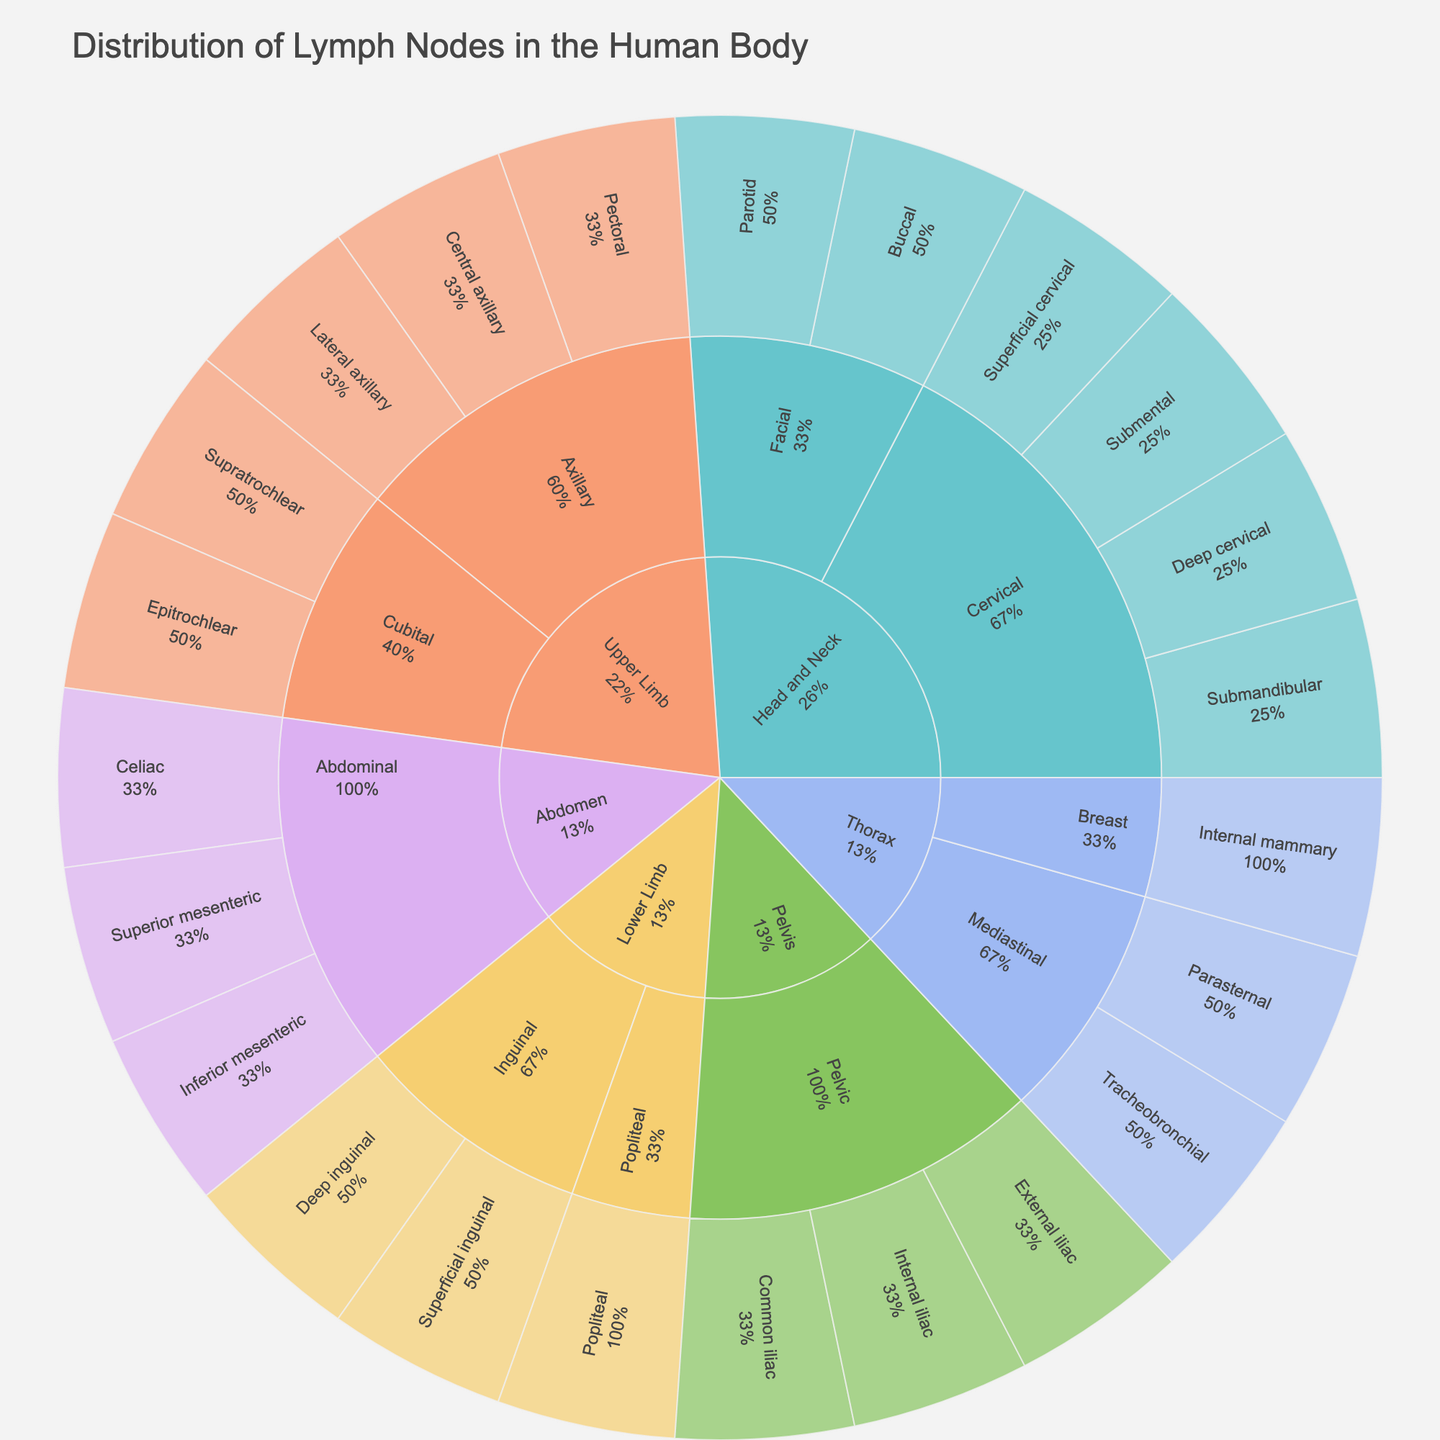What is the title of the sunburst plot? The title is at the top of the figure, indicating the main subject of the plot.
Answer: Distribution of Lymph Nodes in the Human Body How many regions are represented in the sunburst plot? By looking at the outermost ring, we can count the different segments representing distinct regions.
Answer: 6 Which region contains the "Submental" specific node? By tracing the hierarchy, "Submental" belongs under "Head and Neck" followed by "Cervical".
Answer: Head and Neck How many specific nodes are there in the Upper Limb region? By counting the specific nodes under Upper Limb, which include the Axillary and Cubital clusters.
Answer: 5 Which node cluster has the most specific nodes within the Head and Neck region? Compare the number of specific nodes under each cluster within "Head and Neck". The Cervical cluster has the most.
Answer: Cervical Which region does the "Popliteal" specific node belong to? By identifying the node "Popliteal" in the plot and tracing back to the hierarchy it belongs to.
Answer: Lower Limb How many specific nodes are there in total in the plot? Summing all the specific nodes across all regions and clusters. There are 22 specific nodes in total.
Answer: 22 Compare the number of specific nodes in the Thorax and Abdomen regions; which has more? By counting and comparing nodes, Thorax has 3 specific nodes and Abdomen has 3 as well, so they are equal.
Answer: Equal Which specific nodes are part of the Inguinal cluster in the Lower Limb region? By looking under the Lower Limb region and then the Inguinal cluster, the specific nodes are "Superficial inguinal" and "Deep inguinal".
Answer: Superficial inguinal, Deep inguinal 